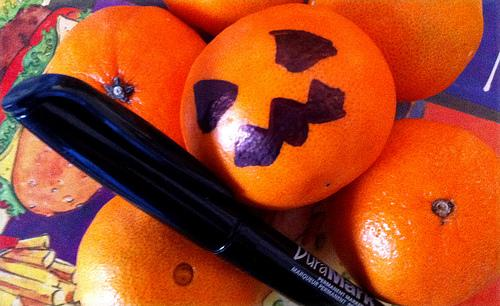Briefly discuss the predominant objects and their specifics in the image. The image captures a table with a black Duramark marker and several oranges (one with a pumpkin-style face), all resting on a tablecloth displaying images of different foods. Give a succinct account of the main components in the image and their characteristics. The image mainly consists of a table with a black permanent marker, a collection of oranges (one featuring a pumpkin face), and a tablecloth that has food images. Write a concise summary of the primary components found in the photo. This photo features a table setting with a black permanent marker, a group of oranges (one with a Halloween pumpkin face), and a food-inspired pattern on the tablecloth. Briefly explain the main visual elements in the image. In the image, there is a table with a black marker and several oranges, one with a face like a pumpkin, all on a tablecloth adorned with images of a hamburger and fries. Enumerate the key subjects in the picture and their details. 1. Black Duramark marker – smooth, colored black; 2. Oranges – round, one with stem and pumpkin-like face; 3. Tablecloth – depictions of hamburger and fries. Provide an overview of the key objects in this picture. The photo displays a table with a black Duramark marker, several oranges including one with a drawn face, and a tablecloth portraying pictures of food. Explain in short the main items visible and their attributes. We see a table with a black marker, various oranges (one resembling a pumpkin), and a tablecloth that has drawings of a hamburger with lettuce and a picture of fries. Quickly outline the major objects and their descriptors found in this picture. In the image, there's a table with a black marker, multiple oranges (one with a Halloween-inspired face), and a tablecloth designed with images of a burger and fries. Compose a brief description of the primary elements in the image. A black marker is placed on a table with oranges, one of which has a pumpkin face drawn on it, and the tablecloth features images of a hamburger and french fries. Mention the main components of the scene and their characteristics. The scene consists of a black permanent marker, multiple round-shaped oranges (one with a Halloween pumpkin face), and a tablecloth that has food illustrations on it. 